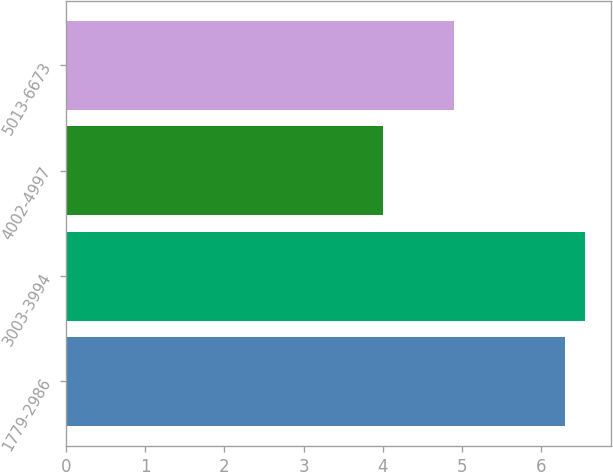Convert chart. <chart><loc_0><loc_0><loc_500><loc_500><bar_chart><fcel>1779-2986<fcel>3003-3994<fcel>4002-4997<fcel>5013-6673<nl><fcel>6.3<fcel>6.55<fcel>4<fcel>4.9<nl></chart> 